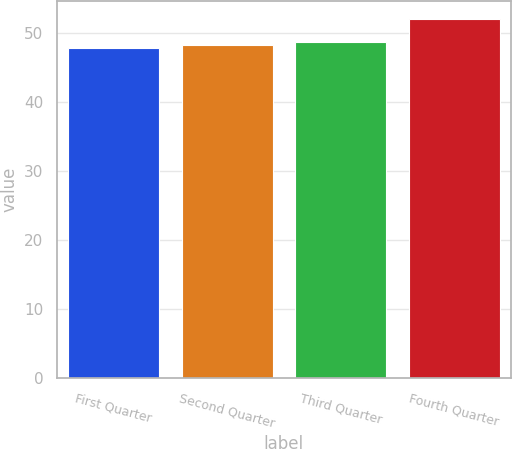<chart> <loc_0><loc_0><loc_500><loc_500><bar_chart><fcel>First Quarter<fcel>Second Quarter<fcel>Third Quarter<fcel>Fourth Quarter<nl><fcel>47.94<fcel>48.36<fcel>48.78<fcel>52.12<nl></chart> 